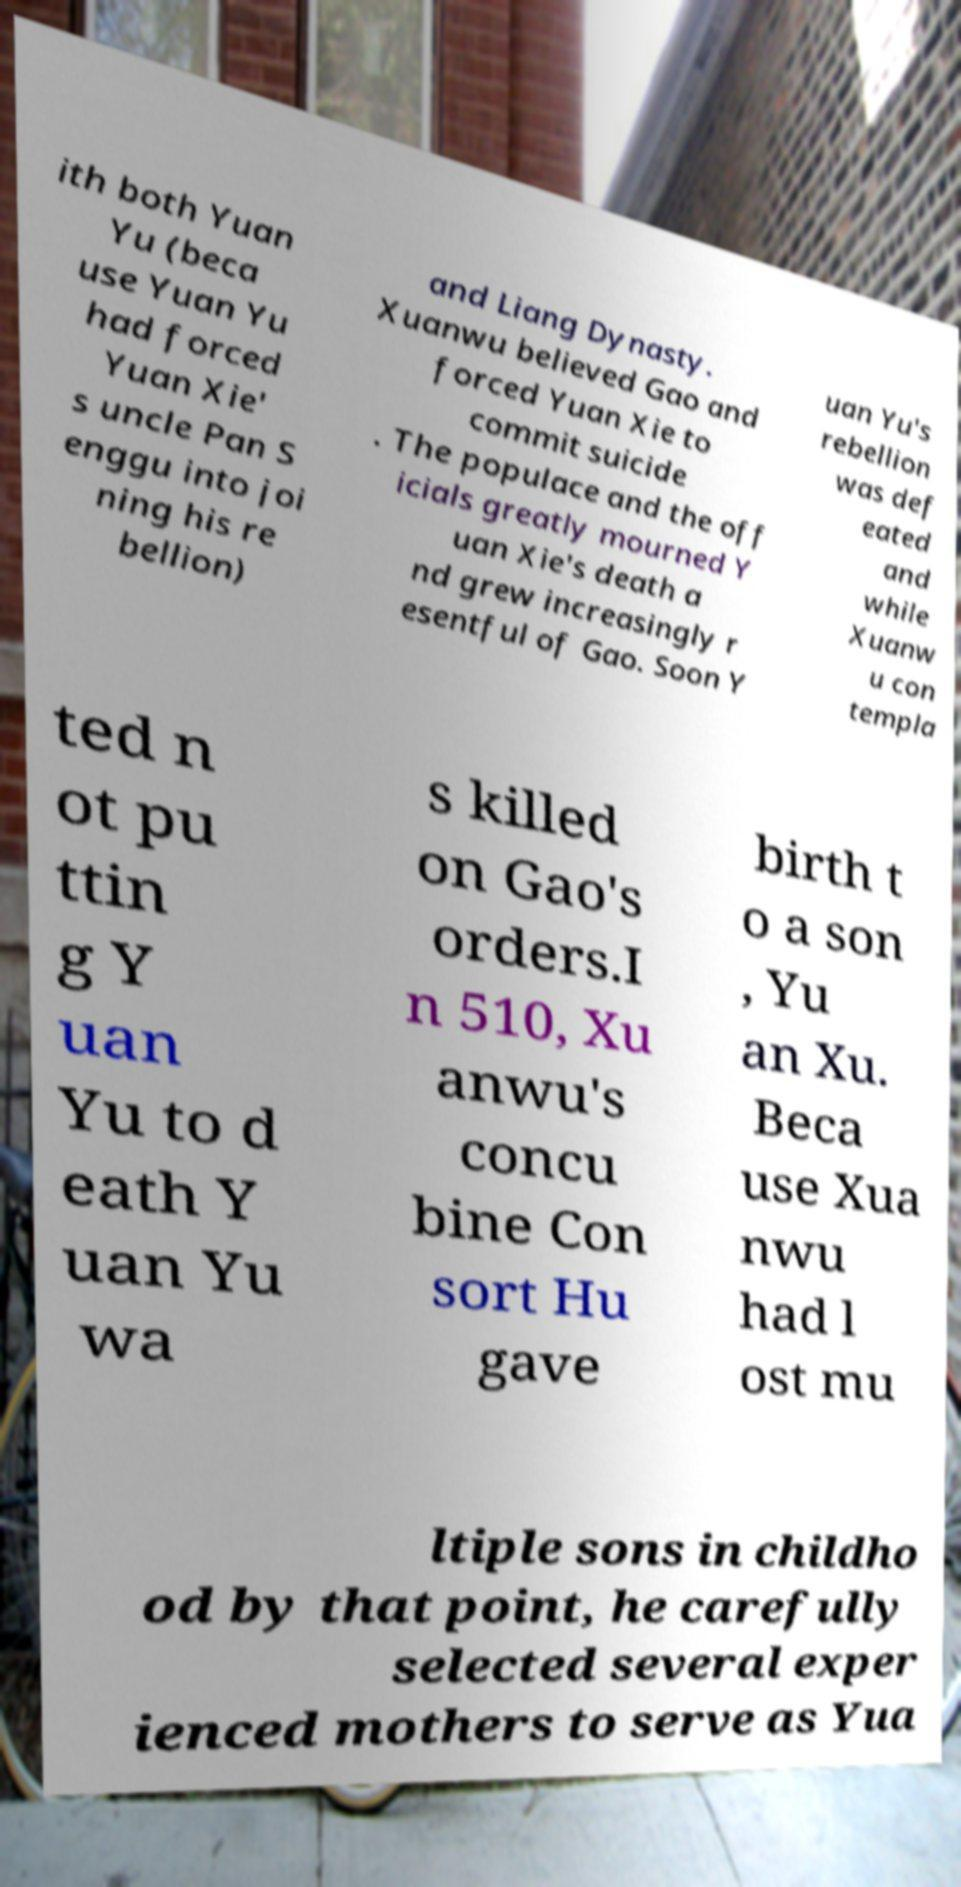Can you accurately transcribe the text from the provided image for me? ith both Yuan Yu (beca use Yuan Yu had forced Yuan Xie' s uncle Pan S enggu into joi ning his re bellion) and Liang Dynasty. Xuanwu believed Gao and forced Yuan Xie to commit suicide . The populace and the off icials greatly mourned Y uan Xie's death a nd grew increasingly r esentful of Gao. Soon Y uan Yu's rebellion was def eated and while Xuanw u con templa ted n ot pu ttin g Y uan Yu to d eath Y uan Yu wa s killed on Gao's orders.I n 510, Xu anwu's concu bine Con sort Hu gave birth t o a son , Yu an Xu. Beca use Xua nwu had l ost mu ltiple sons in childho od by that point, he carefully selected several exper ienced mothers to serve as Yua 